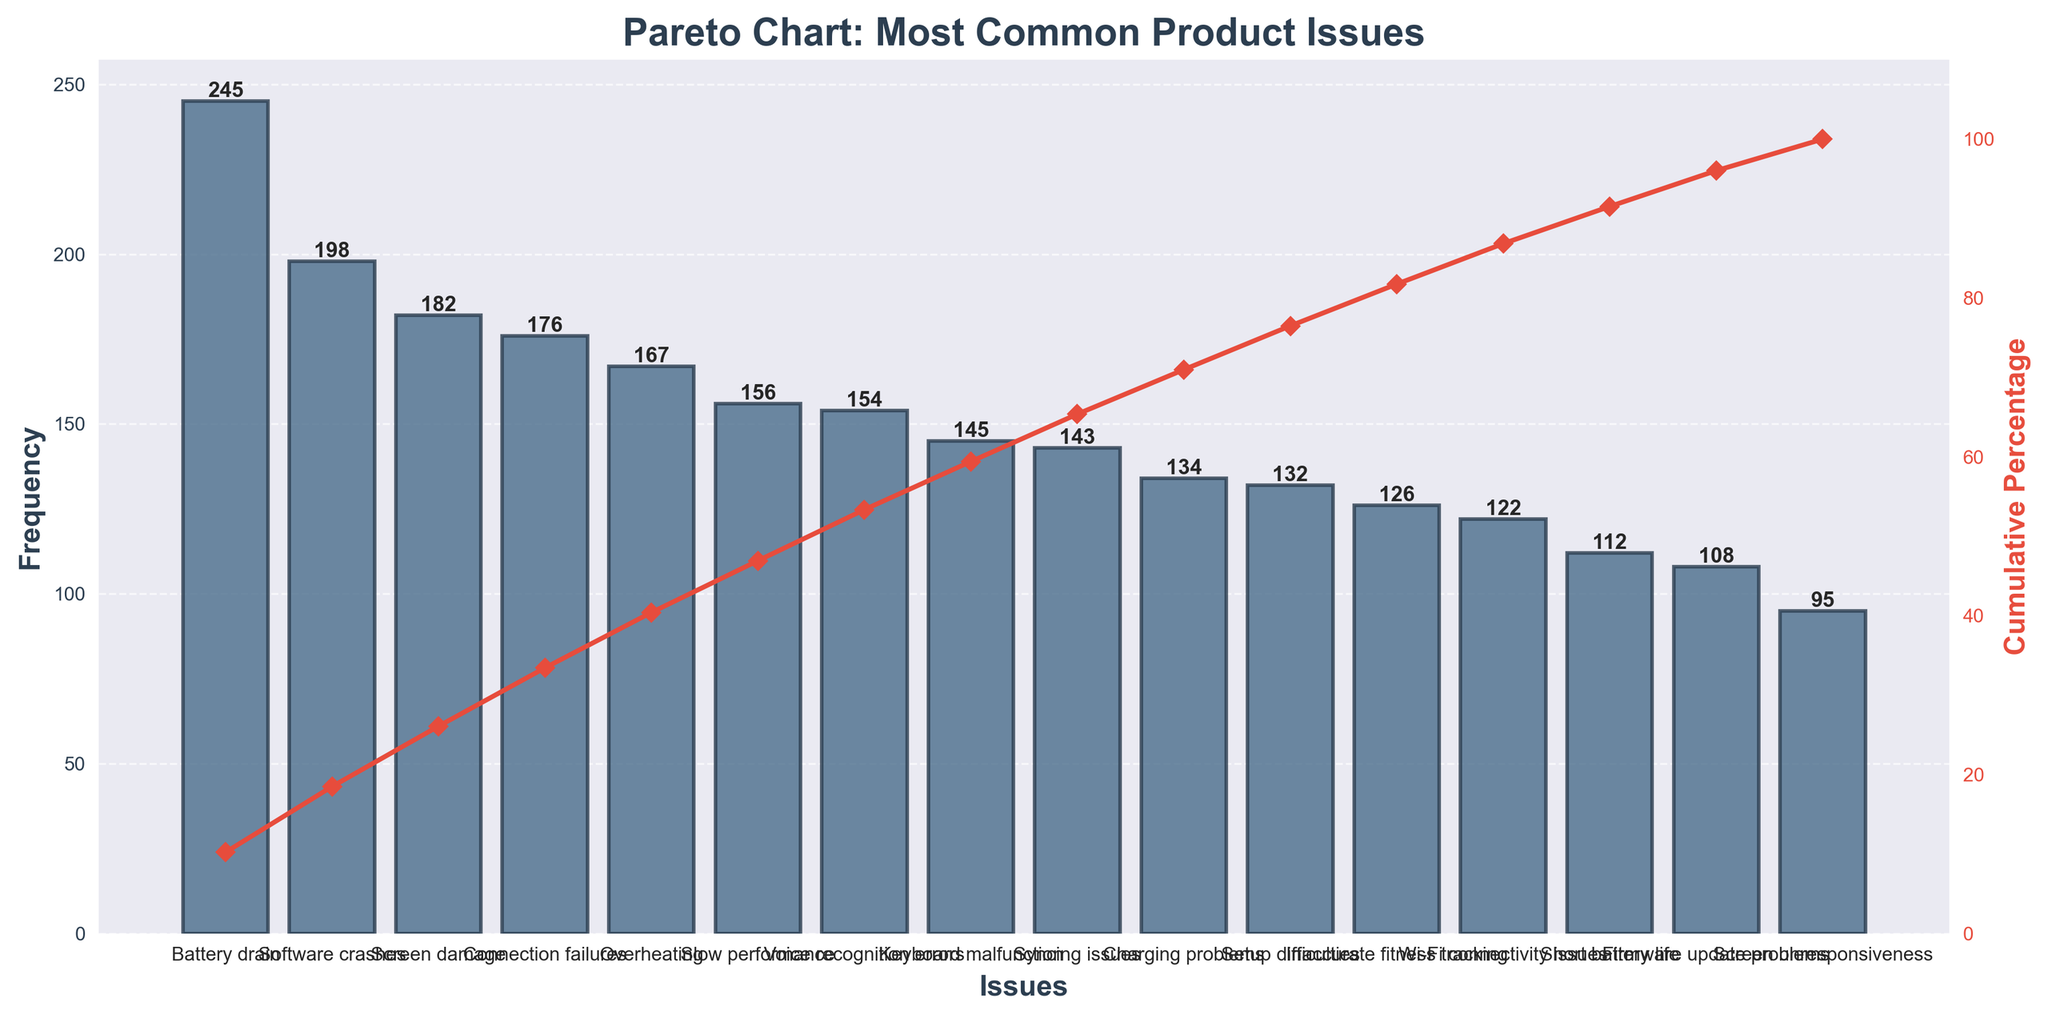How many issues are categorized under the product line of Laptops? To find the number of issues related to Laptops, check the categories listed in the figure. There are four issues listed under Laptops.
Answer: 4 What is the most frequently reported issue across all product lines? To identify the most reported issue, look for the tallest bar in the chart, which represents the highest frequency. The "Battery drain" issue in Smartphones has the highest frequency of 245.
Answer: Battery drain What is the cumulative percentage after adding the top three most frequent issues? Check the cumulative percentage curve and sum the top three frequencies. The issues with frequencies 245, 198, and 182 respectively sum up to 625. The total frequency is 2295. So, (625/2295) * 100 ≈ 27.2%.
Answer: 27.2% Which product line has the issue with the lowest frequency and what is that frequency? Scan the frequencies for the lowest value. The lowest frequency is for "Screen unresponsiveness" in Wearables, which is 95.
Answer: Wearables, 95 Which issue has just surpassed 50% in the cumulative percentage? Follow the cumulative percentage line to identify the issue marking just above the 50% threshold. This issue relates to the "Screen damage" in Smartphones.
Answer: Screen damage What are the top two issues for Smart Home Devices by frequency? Locate the bars for Smart Home Devices and check the two with the highest frequencies. "Connection failures" (176) and "Voice recognition errors" (154) are the top two.
Answer: Connection failures, Voice recognition errors Compare the frequency of 'Software crashes' with 'Battery drain'. How much less is it? Compare the bar values for these issues. "Software crashes" in Laptops (198) and "Battery drain" in Smartphones (245). The difference is 245 - 198 = 47.
Answer: 47 What percentage of the cumulative frequency is contributed by "Overheating" and "Wi-Fi connectivity issues" combined? Sum the frequencies for "Overheating" and "Wi-Fi connectivity issues", which are 167 and 122 respectively, making a total of 289. Total frequency is 2295. So, (289/2295) * 100 ≈ 12.6%.
Answer: 12.6 Which product line has the most diverse range of issues by category count, and how many categories does it have? Count the unique issues for each product line and identify the one with the highest count. Both Smartphones and Laptops have 4 categories each.
Answer: Smartphones, Laptops, 4 How many issues have a frequency greater than 150? Count the number of bars with a height greater than 150. There are 6 such issues.
Answer: 6 